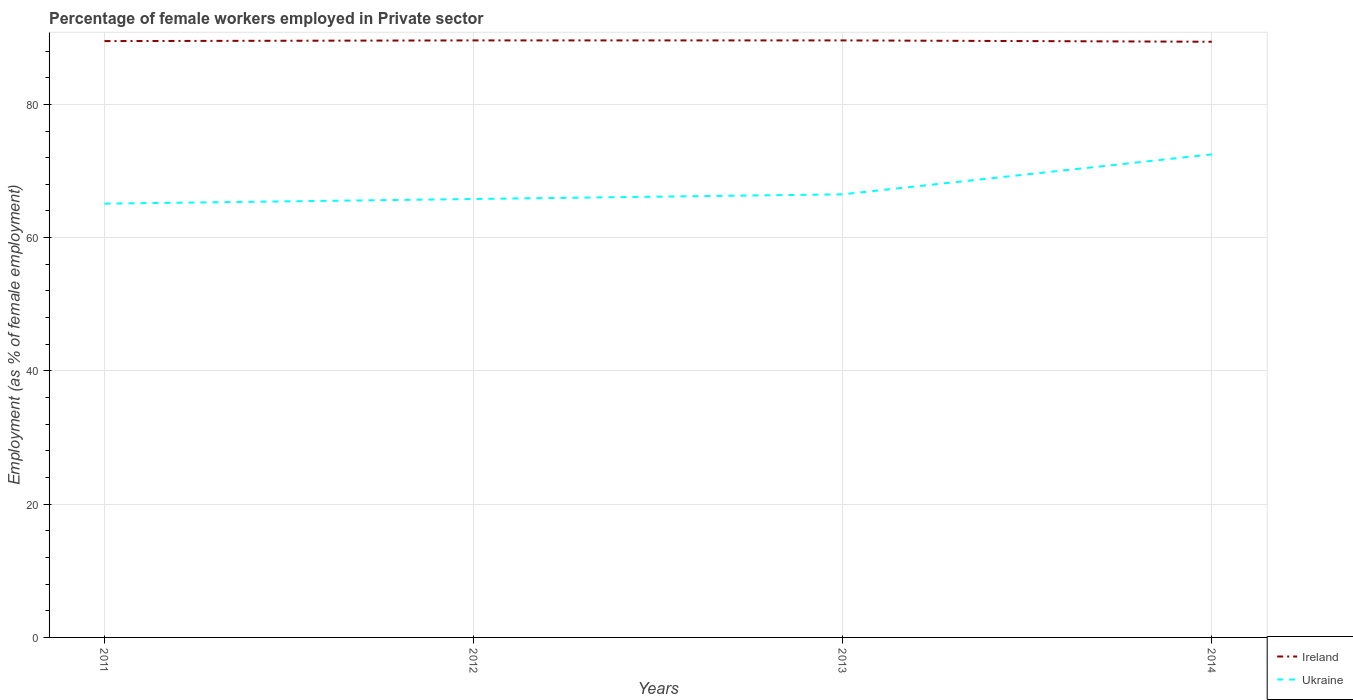Across all years, what is the maximum percentage of females employed in Private sector in Ukraine?
Make the answer very short. 65.1. In which year was the percentage of females employed in Private sector in Ukraine maximum?
Your answer should be compact. 2011. What is the total percentage of females employed in Private sector in Ireland in the graph?
Ensure brevity in your answer.  -0.1. What is the difference between the highest and the second highest percentage of females employed in Private sector in Ireland?
Provide a short and direct response. 0.2. Is the percentage of females employed in Private sector in Ireland strictly greater than the percentage of females employed in Private sector in Ukraine over the years?
Offer a very short reply. No. How many lines are there?
Offer a very short reply. 2. Where does the legend appear in the graph?
Your response must be concise. Bottom right. How many legend labels are there?
Your response must be concise. 2. How are the legend labels stacked?
Provide a short and direct response. Vertical. What is the title of the graph?
Offer a very short reply. Percentage of female workers employed in Private sector. What is the label or title of the X-axis?
Ensure brevity in your answer.  Years. What is the label or title of the Y-axis?
Make the answer very short. Employment (as % of female employment). What is the Employment (as % of female employment) of Ireland in 2011?
Your response must be concise. 89.5. What is the Employment (as % of female employment) in Ukraine in 2011?
Keep it short and to the point. 65.1. What is the Employment (as % of female employment) of Ireland in 2012?
Offer a terse response. 89.6. What is the Employment (as % of female employment) of Ukraine in 2012?
Your answer should be compact. 65.8. What is the Employment (as % of female employment) of Ireland in 2013?
Your answer should be very brief. 89.6. What is the Employment (as % of female employment) in Ukraine in 2013?
Offer a terse response. 66.5. What is the Employment (as % of female employment) of Ireland in 2014?
Offer a terse response. 89.4. What is the Employment (as % of female employment) in Ukraine in 2014?
Make the answer very short. 72.5. Across all years, what is the maximum Employment (as % of female employment) in Ireland?
Your answer should be compact. 89.6. Across all years, what is the maximum Employment (as % of female employment) in Ukraine?
Offer a terse response. 72.5. Across all years, what is the minimum Employment (as % of female employment) in Ireland?
Your answer should be very brief. 89.4. Across all years, what is the minimum Employment (as % of female employment) of Ukraine?
Your response must be concise. 65.1. What is the total Employment (as % of female employment) of Ireland in the graph?
Your answer should be very brief. 358.1. What is the total Employment (as % of female employment) in Ukraine in the graph?
Your response must be concise. 269.9. What is the difference between the Employment (as % of female employment) in Ireland in 2011 and that in 2012?
Give a very brief answer. -0.1. What is the difference between the Employment (as % of female employment) of Ireland in 2011 and that in 2013?
Provide a short and direct response. -0.1. What is the difference between the Employment (as % of female employment) of Ireland in 2012 and that in 2013?
Your answer should be very brief. 0. What is the difference between the Employment (as % of female employment) of Ukraine in 2012 and that in 2013?
Provide a short and direct response. -0.7. What is the difference between the Employment (as % of female employment) of Ukraine in 2013 and that in 2014?
Give a very brief answer. -6. What is the difference between the Employment (as % of female employment) of Ireland in 2011 and the Employment (as % of female employment) of Ukraine in 2012?
Your response must be concise. 23.7. What is the difference between the Employment (as % of female employment) of Ireland in 2011 and the Employment (as % of female employment) of Ukraine in 2013?
Provide a short and direct response. 23. What is the difference between the Employment (as % of female employment) of Ireland in 2011 and the Employment (as % of female employment) of Ukraine in 2014?
Your response must be concise. 17. What is the difference between the Employment (as % of female employment) of Ireland in 2012 and the Employment (as % of female employment) of Ukraine in 2013?
Your response must be concise. 23.1. What is the difference between the Employment (as % of female employment) of Ireland in 2012 and the Employment (as % of female employment) of Ukraine in 2014?
Keep it short and to the point. 17.1. What is the difference between the Employment (as % of female employment) of Ireland in 2013 and the Employment (as % of female employment) of Ukraine in 2014?
Give a very brief answer. 17.1. What is the average Employment (as % of female employment) in Ireland per year?
Keep it short and to the point. 89.53. What is the average Employment (as % of female employment) of Ukraine per year?
Offer a very short reply. 67.47. In the year 2011, what is the difference between the Employment (as % of female employment) in Ireland and Employment (as % of female employment) in Ukraine?
Your answer should be compact. 24.4. In the year 2012, what is the difference between the Employment (as % of female employment) in Ireland and Employment (as % of female employment) in Ukraine?
Provide a short and direct response. 23.8. In the year 2013, what is the difference between the Employment (as % of female employment) in Ireland and Employment (as % of female employment) in Ukraine?
Provide a succinct answer. 23.1. In the year 2014, what is the difference between the Employment (as % of female employment) of Ireland and Employment (as % of female employment) of Ukraine?
Your answer should be very brief. 16.9. What is the ratio of the Employment (as % of female employment) of Ireland in 2011 to that in 2012?
Ensure brevity in your answer.  1. What is the ratio of the Employment (as % of female employment) in Ukraine in 2011 to that in 2013?
Keep it short and to the point. 0.98. What is the ratio of the Employment (as % of female employment) in Ukraine in 2011 to that in 2014?
Your answer should be very brief. 0.9. What is the ratio of the Employment (as % of female employment) of Ireland in 2012 to that in 2013?
Offer a very short reply. 1. What is the ratio of the Employment (as % of female employment) of Ukraine in 2012 to that in 2013?
Your response must be concise. 0.99. What is the ratio of the Employment (as % of female employment) in Ukraine in 2012 to that in 2014?
Keep it short and to the point. 0.91. What is the ratio of the Employment (as % of female employment) of Ireland in 2013 to that in 2014?
Your answer should be compact. 1. What is the ratio of the Employment (as % of female employment) in Ukraine in 2013 to that in 2014?
Your answer should be very brief. 0.92. What is the difference between the highest and the lowest Employment (as % of female employment) in Ukraine?
Ensure brevity in your answer.  7.4. 